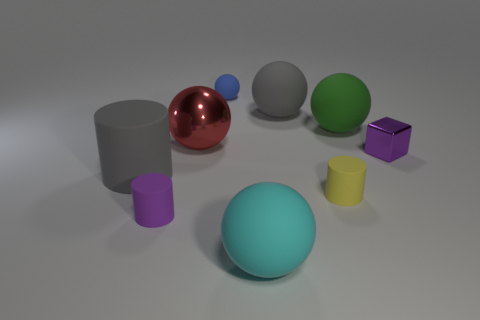Subtract all gray spheres. How many spheres are left? 4 Subtract all large cyan spheres. How many spheres are left? 4 Subtract all yellow spheres. Subtract all red blocks. How many spheres are left? 5 Add 1 tiny cubes. How many objects exist? 10 Subtract all cubes. How many objects are left? 8 Add 5 large shiny things. How many large shiny things exist? 6 Subtract 0 cyan cylinders. How many objects are left? 9 Subtract all big matte balls. Subtract all small cyan objects. How many objects are left? 6 Add 6 blue balls. How many blue balls are left? 7 